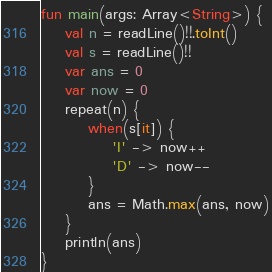Convert code to text. <code><loc_0><loc_0><loc_500><loc_500><_Kotlin_>fun main(args: Array<String>) {
    val n = readLine()!!.toInt()
    val s = readLine()!!
    var ans = 0
    var now = 0
    repeat(n) {
        when(s[it]) {
            'I' -> now++
            'D' -> now--
        }
        ans = Math.max(ans, now)
    }
    println(ans)
}
</code> 